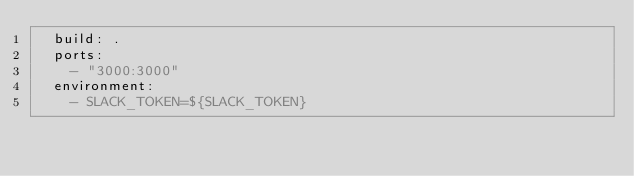Convert code to text. <code><loc_0><loc_0><loc_500><loc_500><_YAML_>  build: .
  ports:
    - "3000:3000"
  environment:
    - SLACK_TOKEN=${SLACK_TOKEN}
</code> 